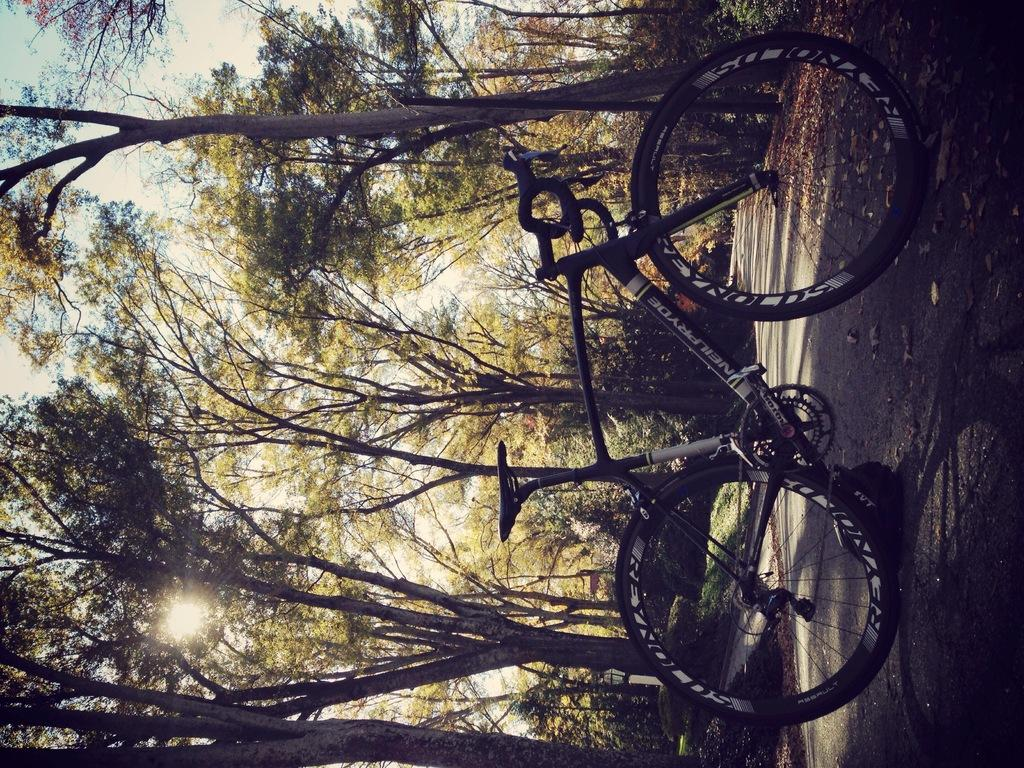What is the main object in the image? There is a bicycle in the image. What is on the road in the image? Dried leaves are present on the road in the image. What can be seen in the background of the image? There are plants, trees, and the sky visible in the background of the image. How many credits are visible on the bicycle in the image? There are no credits present on the bicycle or in the image. What type of roll can be seen being performed by the trees in the image? There is no roll being performed by the trees or any other objects in the image; the trees are stationary. 